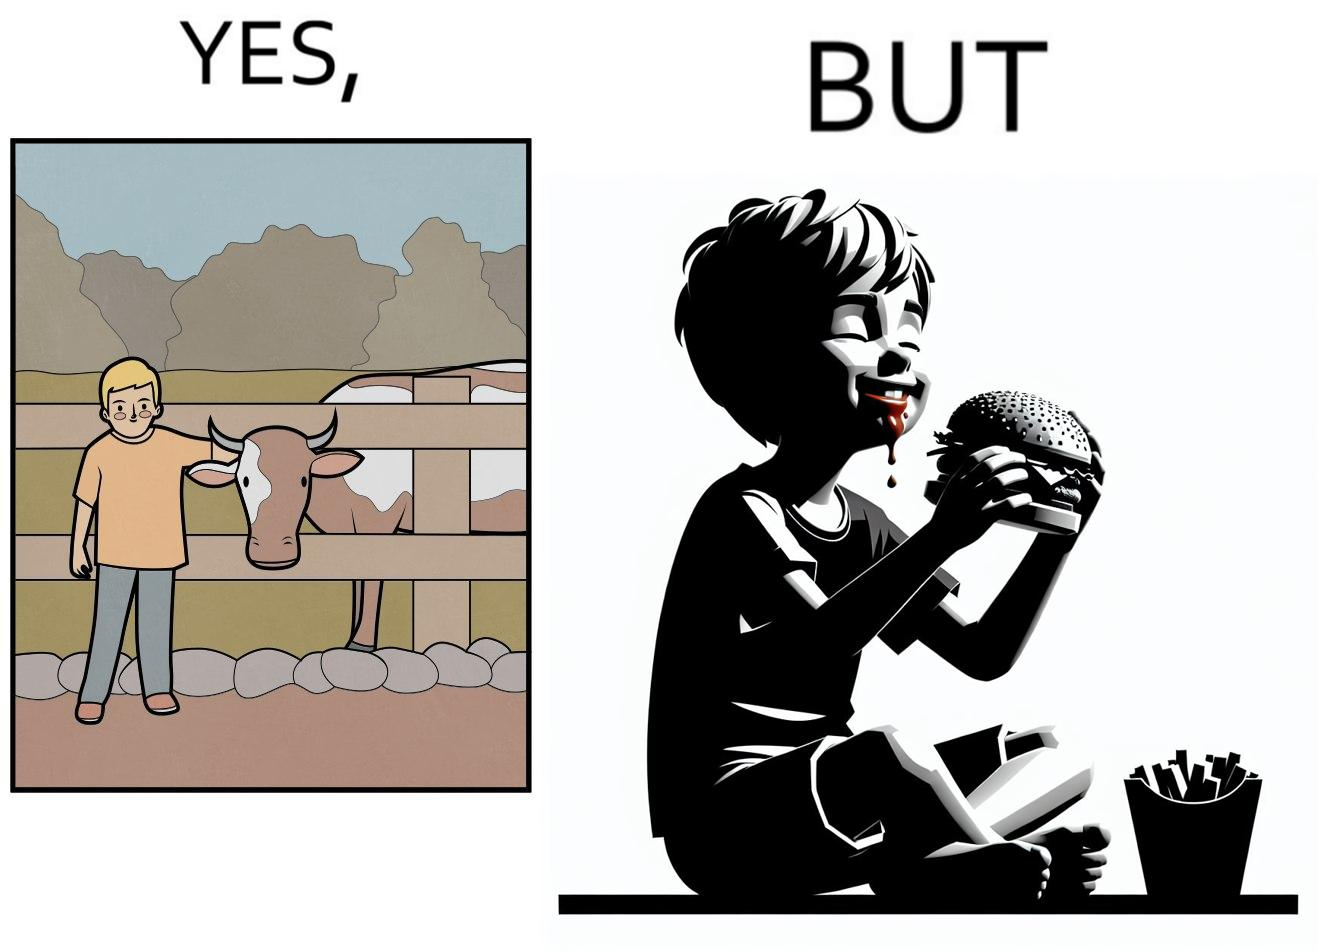Describe what you see in this image. The irony is that the boy is petting the cow to show that he cares about the animal, but then he also eats hamburgers made from the same cows 